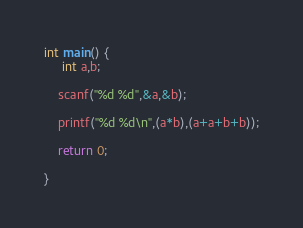Convert code to text. <code><loc_0><loc_0><loc_500><loc_500><_C_>int main() {
     int a,b;
    
    scanf("%d %d",&a,&b);
    
    printf("%d %d\n",(a*b),(a+a+b+b));
    
    return 0;

}</code> 